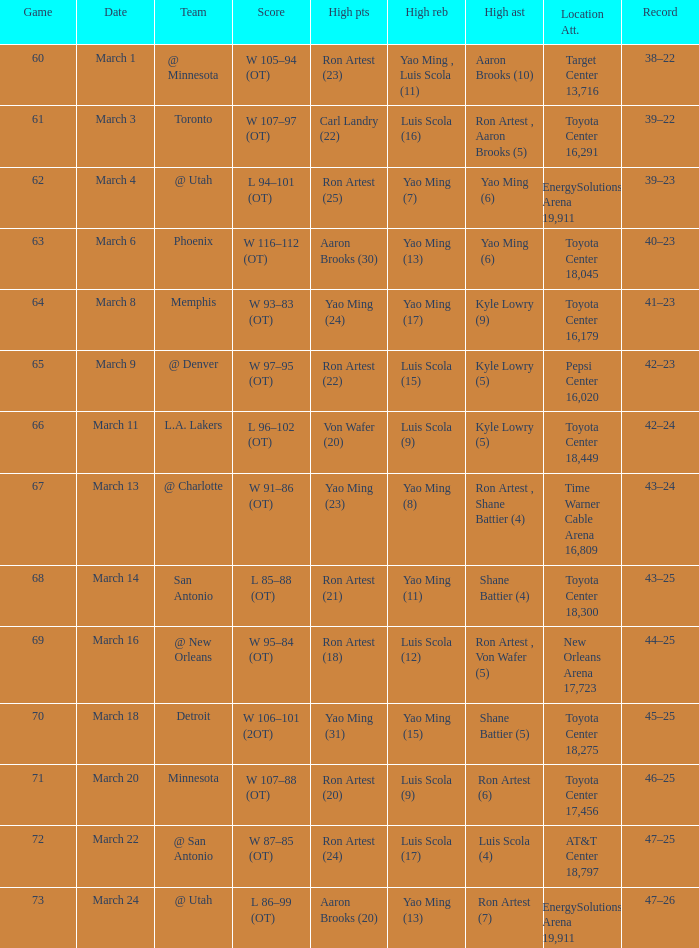On what date did the Rockets play Memphis? March 8. Parse the table in full. {'header': ['Game', 'Date', 'Team', 'Score', 'High pts', 'High reb', 'High ast', 'Location Att.', 'Record'], 'rows': [['60', 'March 1', '@ Minnesota', 'W 105–94 (OT)', 'Ron Artest (23)', 'Yao Ming , Luis Scola (11)', 'Aaron Brooks (10)', 'Target Center 13,716', '38–22'], ['61', 'March 3', 'Toronto', 'W 107–97 (OT)', 'Carl Landry (22)', 'Luis Scola (16)', 'Ron Artest , Aaron Brooks (5)', 'Toyota Center 16,291', '39–22'], ['62', 'March 4', '@ Utah', 'L 94–101 (OT)', 'Ron Artest (25)', 'Yao Ming (7)', 'Yao Ming (6)', 'EnergySolutions Arena 19,911', '39–23'], ['63', 'March 6', 'Phoenix', 'W 116–112 (OT)', 'Aaron Brooks (30)', 'Yao Ming (13)', 'Yao Ming (6)', 'Toyota Center 18,045', '40–23'], ['64', 'March 8', 'Memphis', 'W 93–83 (OT)', 'Yao Ming (24)', 'Yao Ming (17)', 'Kyle Lowry (9)', 'Toyota Center 16,179', '41–23'], ['65', 'March 9', '@ Denver', 'W 97–95 (OT)', 'Ron Artest (22)', 'Luis Scola (15)', 'Kyle Lowry (5)', 'Pepsi Center 16,020', '42–23'], ['66', 'March 11', 'L.A. Lakers', 'L 96–102 (OT)', 'Von Wafer (20)', 'Luis Scola (9)', 'Kyle Lowry (5)', 'Toyota Center 18,449', '42–24'], ['67', 'March 13', '@ Charlotte', 'W 91–86 (OT)', 'Yao Ming (23)', 'Yao Ming (8)', 'Ron Artest , Shane Battier (4)', 'Time Warner Cable Arena 16,809', '43–24'], ['68', 'March 14', 'San Antonio', 'L 85–88 (OT)', 'Ron Artest (21)', 'Yao Ming (11)', 'Shane Battier (4)', 'Toyota Center 18,300', '43–25'], ['69', 'March 16', '@ New Orleans', 'W 95–84 (OT)', 'Ron Artest (18)', 'Luis Scola (12)', 'Ron Artest , Von Wafer (5)', 'New Orleans Arena 17,723', '44–25'], ['70', 'March 18', 'Detroit', 'W 106–101 (2OT)', 'Yao Ming (31)', 'Yao Ming (15)', 'Shane Battier (5)', 'Toyota Center 18,275', '45–25'], ['71', 'March 20', 'Minnesota', 'W 107–88 (OT)', 'Ron Artest (20)', 'Luis Scola (9)', 'Ron Artest (6)', 'Toyota Center 17,456', '46–25'], ['72', 'March 22', '@ San Antonio', 'W 87–85 (OT)', 'Ron Artest (24)', 'Luis Scola (17)', 'Luis Scola (4)', 'AT&T Center 18,797', '47–25'], ['73', 'March 24', '@ Utah', 'L 86–99 (OT)', 'Aaron Brooks (20)', 'Yao Ming (13)', 'Ron Artest (7)', 'EnergySolutions Arena 19,911', '47–26']]} 